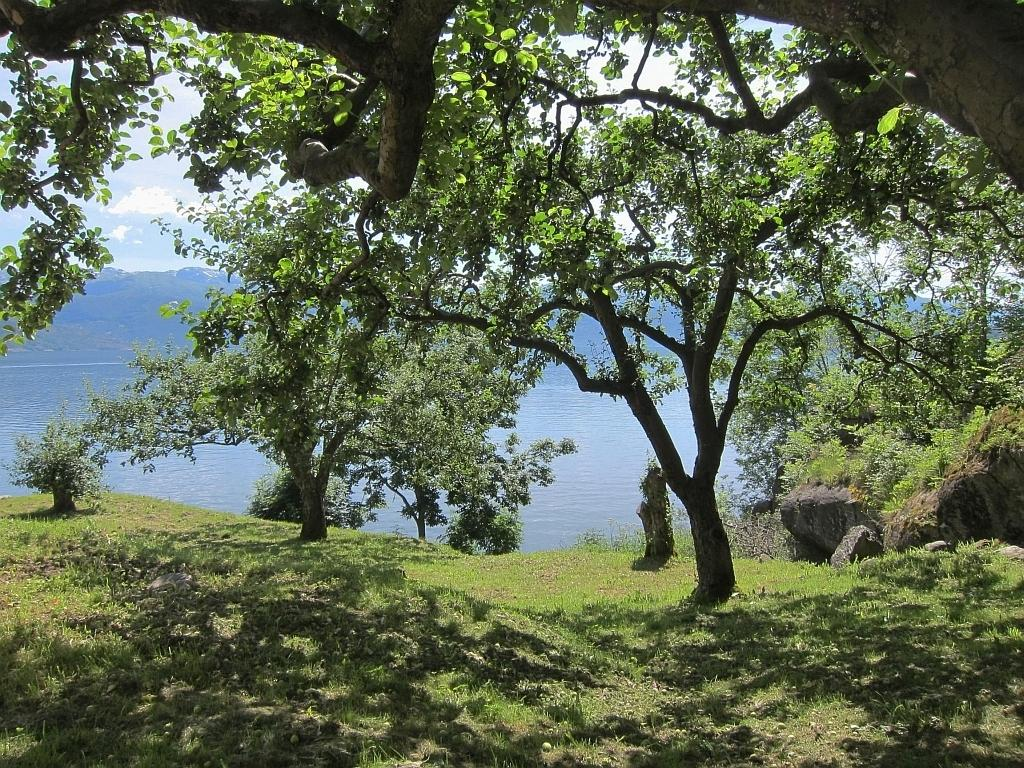What type of vegetation can be seen in the image? There is grass and trees in the image. What other natural elements are present in the image? There are rocks in the image. What can be seen in the background of the image? Water and the sky are visible in the background of the image. What type of toy is floating on the water in the image? There is no toy present in the image; it only features grass, trees, rocks, water, and the sky. What year is depicted in the image? The image does not depict a specific year; it is a snapshot of a natural scene. 